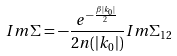<formula> <loc_0><loc_0><loc_500><loc_500>I m \Sigma = - \frac { e ^ { - \frac { \beta | k _ { 0 } | } { 2 } } } { 2 n ( | k _ { 0 } | ) } I m \Sigma _ { 1 2 }</formula> 